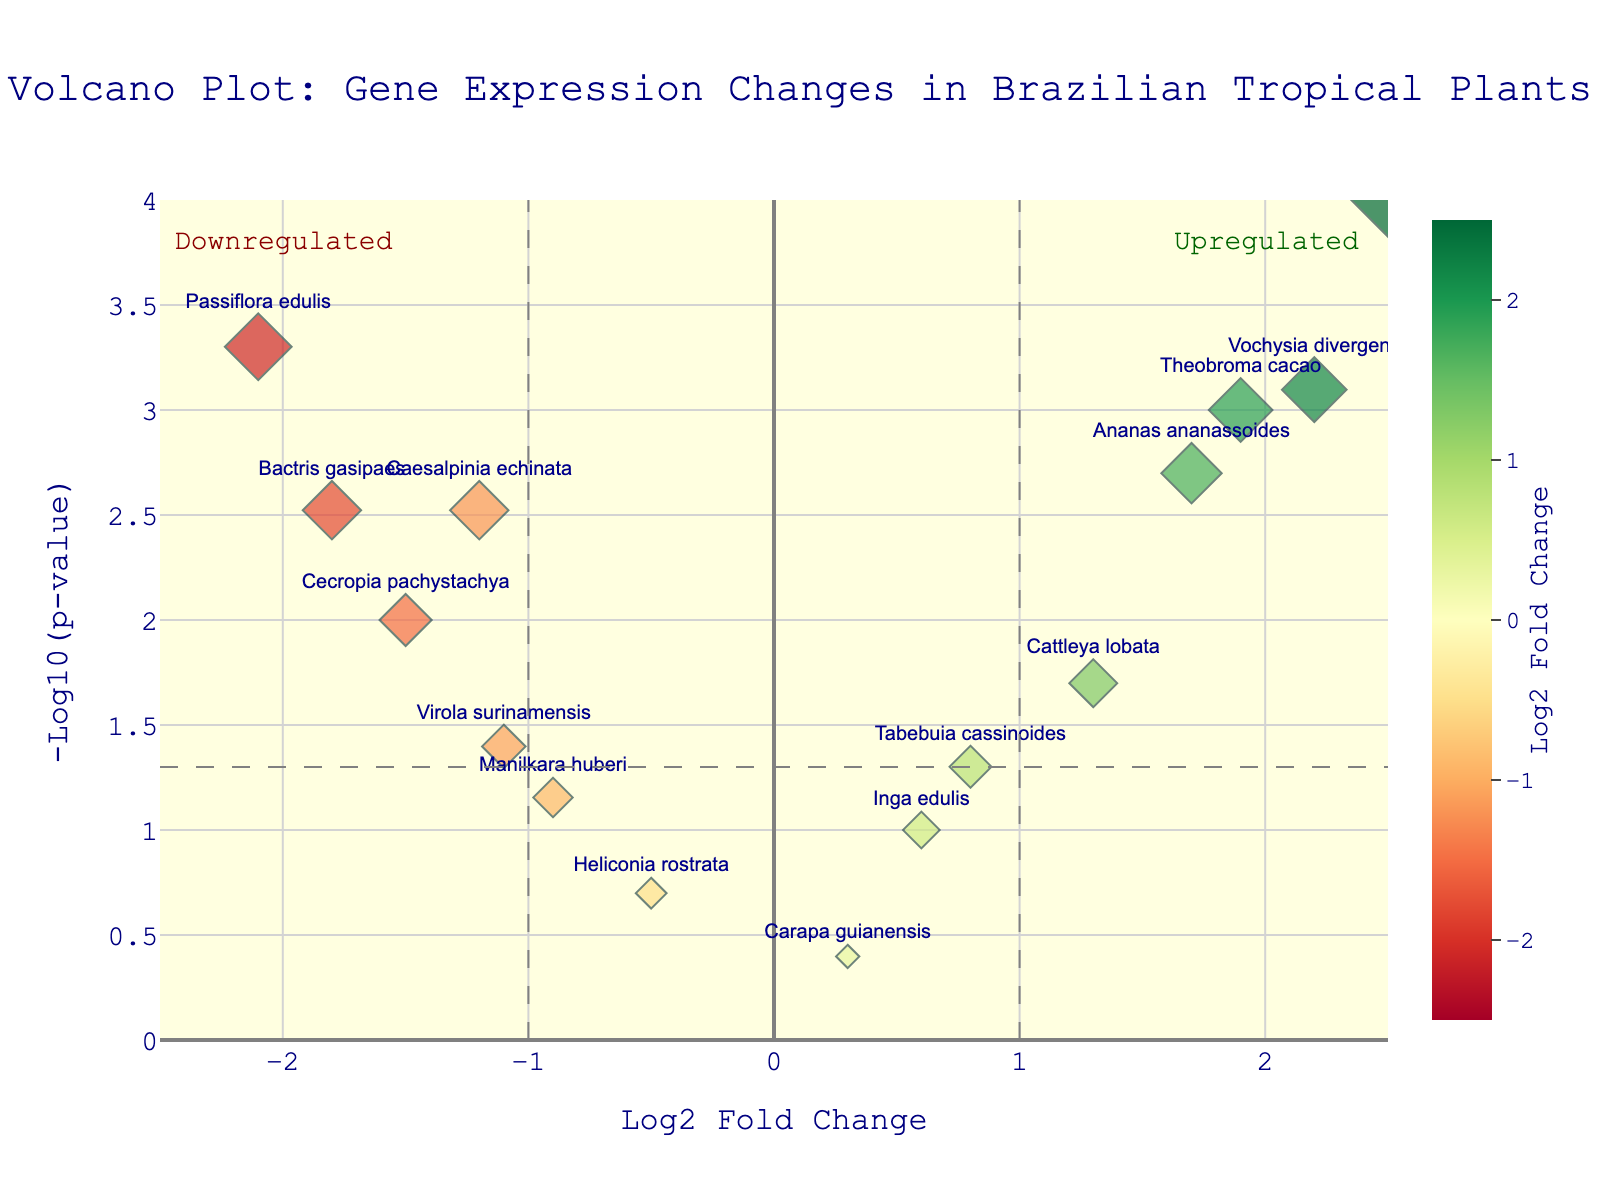What is the title of the figure? The title of a figure is typically shown at the top. In this case, it's clearly provided at the top center of the image.
Answer: Volcano Plot: Gene Expression Changes in Brazilian Tropical Plants Which gene has the highest log2FoldChange? To find the gene with the highest log2FoldChange, we look at the far-right end of the x-axis labeled "Log2 Fold Change." The gene with the highest value will be at the far end.
Answer: Euterpe edulis How many genes have a p-value less than 0.01? To find this, we look at the y-axis labeled as "-Log10(p-value)." A p-value less than 0.01 corresponds to -log10(p-value) greater than 2. We count all points above this threshold.
Answer: 7 Which genes are considered upregulated? Upregulated genes would have positive log2FoldChange values and are generally located to the right of the plot.
Answer: Euterpe edulis, Ananas ananassoides, Theobroma cacao, Vochysia divergens, Cattleya lobata Which gene has the highest -log10(p-value)? The gene with the highest -log10(p-value) will be the highest point on the y-axis.
Answer: Euterpe edulis Are there more upregulated or downregulated genes with significant p-values (p < 0.05)? Significant p-values are those with -log10(p-value) greater than 1.3. Upregulated genes have positive log2FoldChange; downregulated genes have negative values. Count and compare these.
Answer: More downregulated Which gene is the most downregulated? The most downregulated gene is the one with the most negative log2FoldChange value.
Answer: Passiflora edulis Are any genes neither upregulated nor downregulated significantly? These would be genes where the log2FoldChange is close to zero and p-values are not significant (p > 0.05); they would be near the center of the plot horizontally and have low values vertically.
Answer: Heliconia rostrata, Carapa guianensis, Inga edulis 